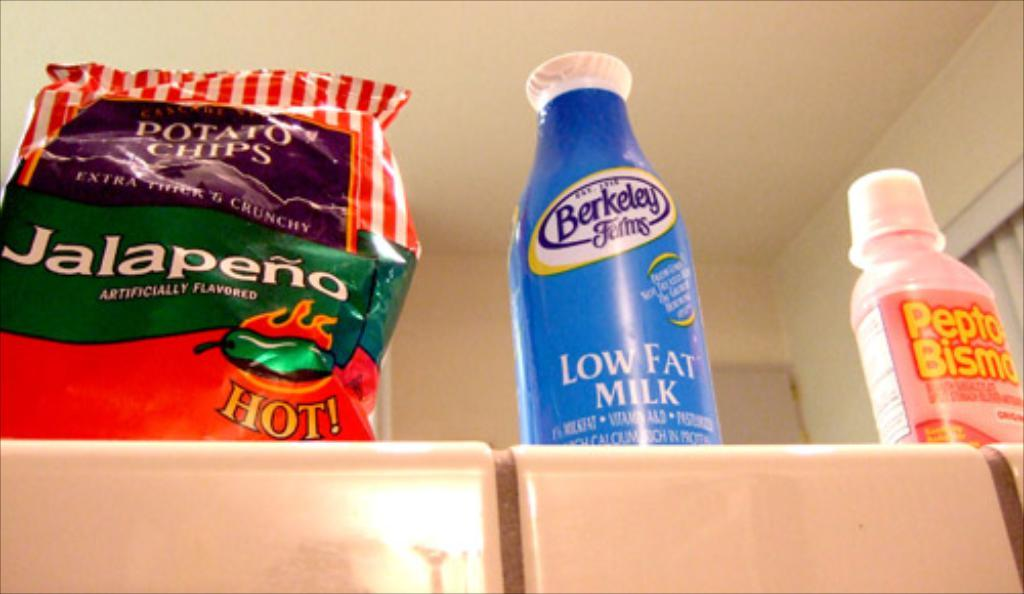<image>
Create a compact narrative representing the image presented. A bag of jalapeno potato chips is left of the milk. 